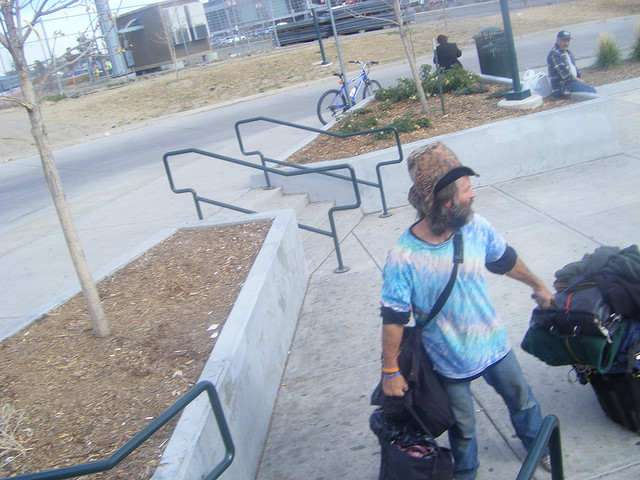<image>What movie character is in the photo? I don't know which movie character is in the photo. The character could be anyone from James Bond to Jack Sparrow. What movie character is in the photo? I don't know which movie character is in the photo. It can be seen 'james bond', 'cowboy', 'homeless dude', 'jack sparrow', 'mickey', 'big lebowski', or 'will smith'. 